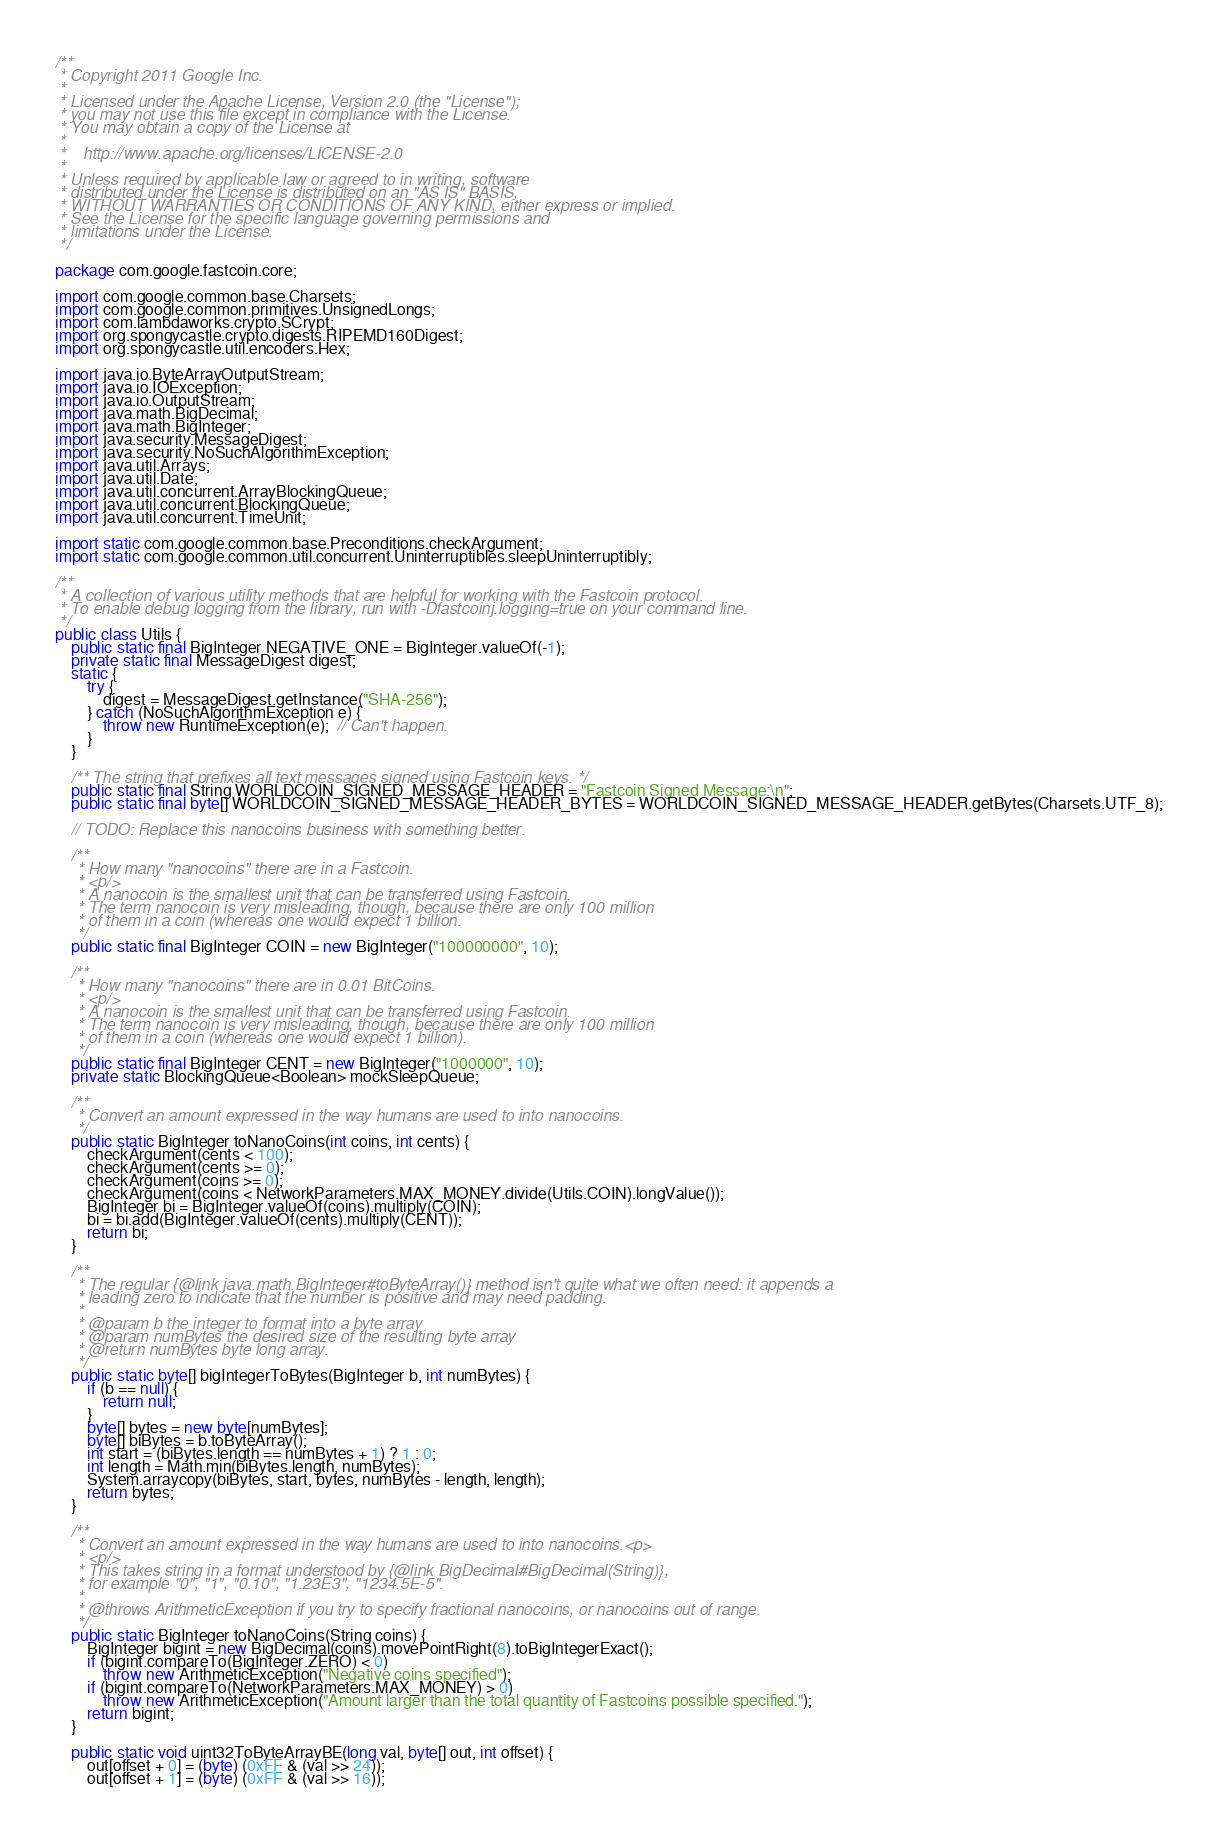<code> <loc_0><loc_0><loc_500><loc_500><_Java_>/**
 * Copyright 2011 Google Inc.
 *
 * Licensed under the Apache License, Version 2.0 (the "License");
 * you may not use this file except in compliance with the License.
 * You may obtain a copy of the License at
 *
 *    http://www.apache.org/licenses/LICENSE-2.0
 *
 * Unless required by applicable law or agreed to in writing, software
 * distributed under the License is distributed on an "AS IS" BASIS,
 * WITHOUT WARRANTIES OR CONDITIONS OF ANY KIND, either express or implied.
 * See the License for the specific language governing permissions and
 * limitations under the License.
 */

package com.google.fastcoin.core;

import com.google.common.base.Charsets;
import com.google.common.primitives.UnsignedLongs;
import com.lambdaworks.crypto.SCrypt;
import org.spongycastle.crypto.digests.RIPEMD160Digest;
import org.spongycastle.util.encoders.Hex;

import java.io.ByteArrayOutputStream;
import java.io.IOException;
import java.io.OutputStream;
import java.math.BigDecimal;
import java.math.BigInteger;
import java.security.MessageDigest;
import java.security.NoSuchAlgorithmException;
import java.util.Arrays;
import java.util.Date;
import java.util.concurrent.ArrayBlockingQueue;
import java.util.concurrent.BlockingQueue;
import java.util.concurrent.TimeUnit;

import static com.google.common.base.Preconditions.checkArgument;
import static com.google.common.util.concurrent.Uninterruptibles.sleepUninterruptibly;

/**
 * A collection of various utility methods that are helpful for working with the Fastcoin protocol.
 * To enable debug logging from the library, run with -Dfastcoinj.logging=true on your command line.
 */
public class Utils {
    public static final BigInteger NEGATIVE_ONE = BigInteger.valueOf(-1);
    private static final MessageDigest digest;
    static {
        try {
            digest = MessageDigest.getInstance("SHA-256");
        } catch (NoSuchAlgorithmException e) {
            throw new RuntimeException(e);  // Can't happen.
        }
    }

    /** The string that prefixes all text messages signed using Fastcoin keys. */
    public static final String WORLDCOIN_SIGNED_MESSAGE_HEADER = "Fastcoin Signed Message:\n";
    public static final byte[] WORLDCOIN_SIGNED_MESSAGE_HEADER_BYTES = WORLDCOIN_SIGNED_MESSAGE_HEADER.getBytes(Charsets.UTF_8);

    // TODO: Replace this nanocoins business with something better.

    /**
     * How many "nanocoins" there are in a Fastcoin.
     * <p/>
     * A nanocoin is the smallest unit that can be transferred using Fastcoin.
     * The term nanocoin is very misleading, though, because there are only 100 million
     * of them in a coin (whereas one would expect 1 billion.
     */
    public static final BigInteger COIN = new BigInteger("100000000", 10);

    /**
     * How many "nanocoins" there are in 0.01 BitCoins.
     * <p/>
     * A nanocoin is the smallest unit that can be transferred using Fastcoin.
     * The term nanocoin is very misleading, though, because there are only 100 million
     * of them in a coin (whereas one would expect 1 billion).
     */
    public static final BigInteger CENT = new BigInteger("1000000", 10);
    private static BlockingQueue<Boolean> mockSleepQueue;

    /**
     * Convert an amount expressed in the way humans are used to into nanocoins.
     */
    public static BigInteger toNanoCoins(int coins, int cents) {
        checkArgument(cents < 100);
        checkArgument(cents >= 0);
        checkArgument(coins >= 0);
        checkArgument(coins < NetworkParameters.MAX_MONEY.divide(Utils.COIN).longValue());
        BigInteger bi = BigInteger.valueOf(coins).multiply(COIN);
        bi = bi.add(BigInteger.valueOf(cents).multiply(CENT));
        return bi;
    }

    /**
     * The regular {@link java.math.BigInteger#toByteArray()} method isn't quite what we often need: it appends a
     * leading zero to indicate that the number is positive and may need padding.
     *
     * @param b the integer to format into a byte array
     * @param numBytes the desired size of the resulting byte array
     * @return numBytes byte long array.
     */
    public static byte[] bigIntegerToBytes(BigInteger b, int numBytes) {
        if (b == null) {
            return null;
        }
        byte[] bytes = new byte[numBytes];
        byte[] biBytes = b.toByteArray();
        int start = (biBytes.length == numBytes + 1) ? 1 : 0;
        int length = Math.min(biBytes.length, numBytes);
        System.arraycopy(biBytes, start, bytes, numBytes - length, length);
        return bytes;        
    }

    /**
     * Convert an amount expressed in the way humans are used to into nanocoins.<p>
     * <p/>
     * This takes string in a format understood by {@link BigDecimal#BigDecimal(String)},
     * for example "0", "1", "0.10", "1.23E3", "1234.5E-5".
     *
     * @throws ArithmeticException if you try to specify fractional nanocoins, or nanocoins out of range.
     */
    public static BigInteger toNanoCoins(String coins) {
        BigInteger bigint = new BigDecimal(coins).movePointRight(8).toBigIntegerExact();
        if (bigint.compareTo(BigInteger.ZERO) < 0)
            throw new ArithmeticException("Negative coins specified");
        if (bigint.compareTo(NetworkParameters.MAX_MONEY) > 0)
            throw new ArithmeticException("Amount larger than the total quantity of Fastcoins possible specified.");
        return bigint;
    }

    public static void uint32ToByteArrayBE(long val, byte[] out, int offset) {
        out[offset + 0] = (byte) (0xFF & (val >> 24));
        out[offset + 1] = (byte) (0xFF & (val >> 16));</code> 